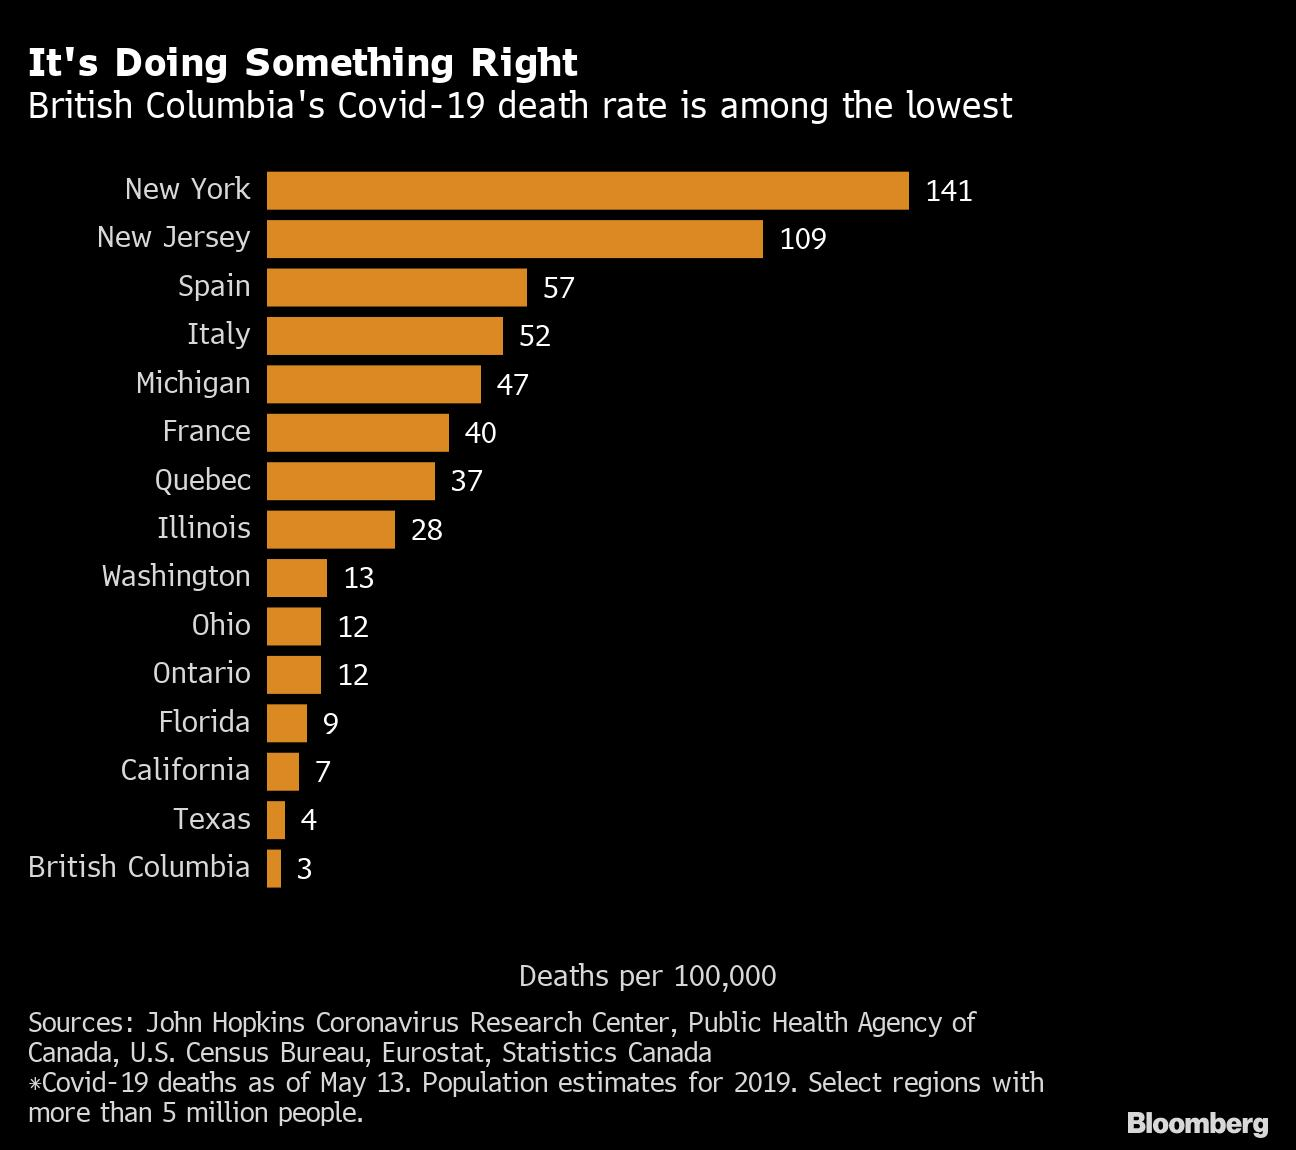Give some essential details in this illustration. As of May 13, the death rate from Covid-19 in Spain is 57. As of May 13, the second-highest Covid-19 death rate has been reported among the selected regions in New Jersey. As of May 13th, the death rate from Covid-19 in France was 40. 